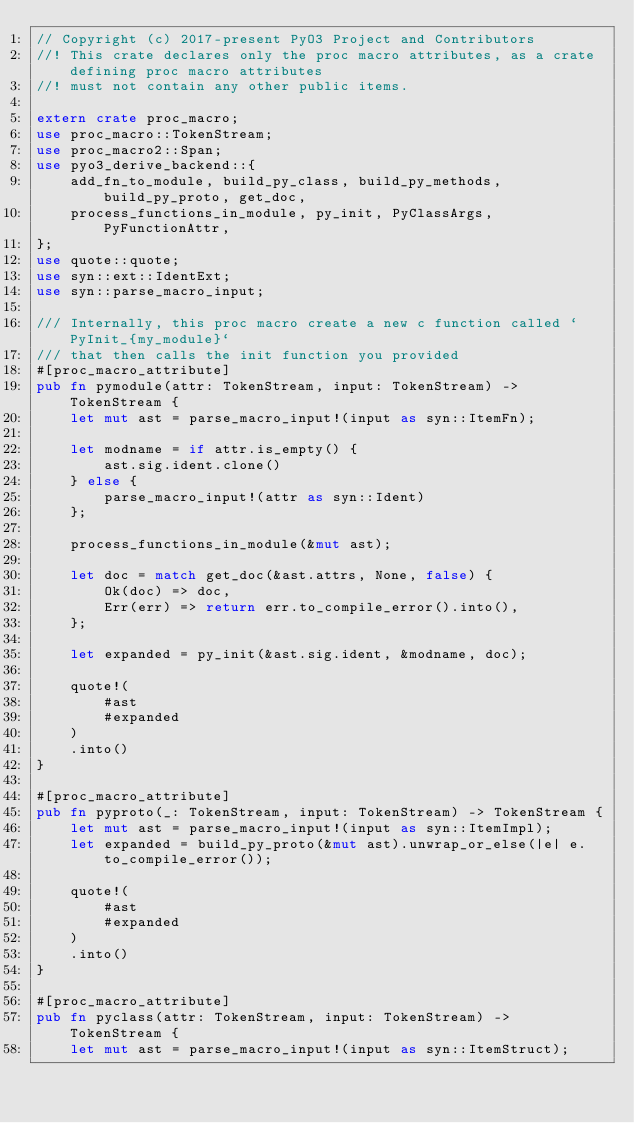Convert code to text. <code><loc_0><loc_0><loc_500><loc_500><_Rust_>// Copyright (c) 2017-present PyO3 Project and Contributors
//! This crate declares only the proc macro attributes, as a crate defining proc macro attributes
//! must not contain any other public items.

extern crate proc_macro;
use proc_macro::TokenStream;
use proc_macro2::Span;
use pyo3_derive_backend::{
    add_fn_to_module, build_py_class, build_py_methods, build_py_proto, get_doc,
    process_functions_in_module, py_init, PyClassArgs, PyFunctionAttr,
};
use quote::quote;
use syn::ext::IdentExt;
use syn::parse_macro_input;

/// Internally, this proc macro create a new c function called `PyInit_{my_module}`
/// that then calls the init function you provided
#[proc_macro_attribute]
pub fn pymodule(attr: TokenStream, input: TokenStream) -> TokenStream {
    let mut ast = parse_macro_input!(input as syn::ItemFn);

    let modname = if attr.is_empty() {
        ast.sig.ident.clone()
    } else {
        parse_macro_input!(attr as syn::Ident)
    };

    process_functions_in_module(&mut ast);

    let doc = match get_doc(&ast.attrs, None, false) {
        Ok(doc) => doc,
        Err(err) => return err.to_compile_error().into(),
    };

    let expanded = py_init(&ast.sig.ident, &modname, doc);

    quote!(
        #ast
        #expanded
    )
    .into()
}

#[proc_macro_attribute]
pub fn pyproto(_: TokenStream, input: TokenStream) -> TokenStream {
    let mut ast = parse_macro_input!(input as syn::ItemImpl);
    let expanded = build_py_proto(&mut ast).unwrap_or_else(|e| e.to_compile_error());

    quote!(
        #ast
        #expanded
    )
    .into()
}

#[proc_macro_attribute]
pub fn pyclass(attr: TokenStream, input: TokenStream) -> TokenStream {
    let mut ast = parse_macro_input!(input as syn::ItemStruct);</code> 